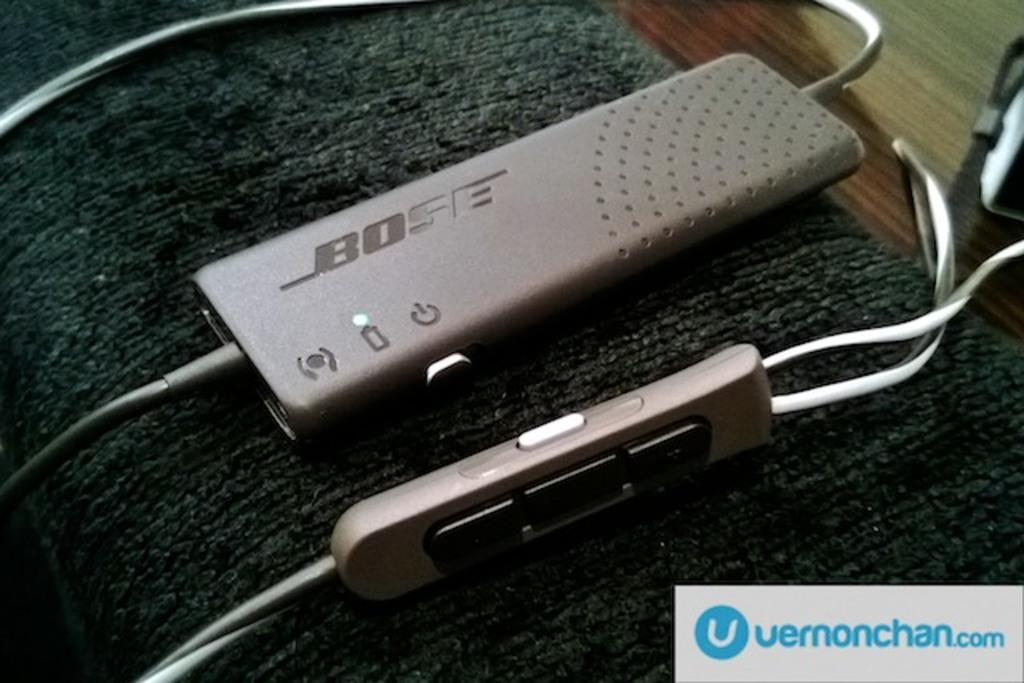<image>
Give a short and clear explanation of the subsequent image. A small electronic device by Bose sits on a plush arm rest. 